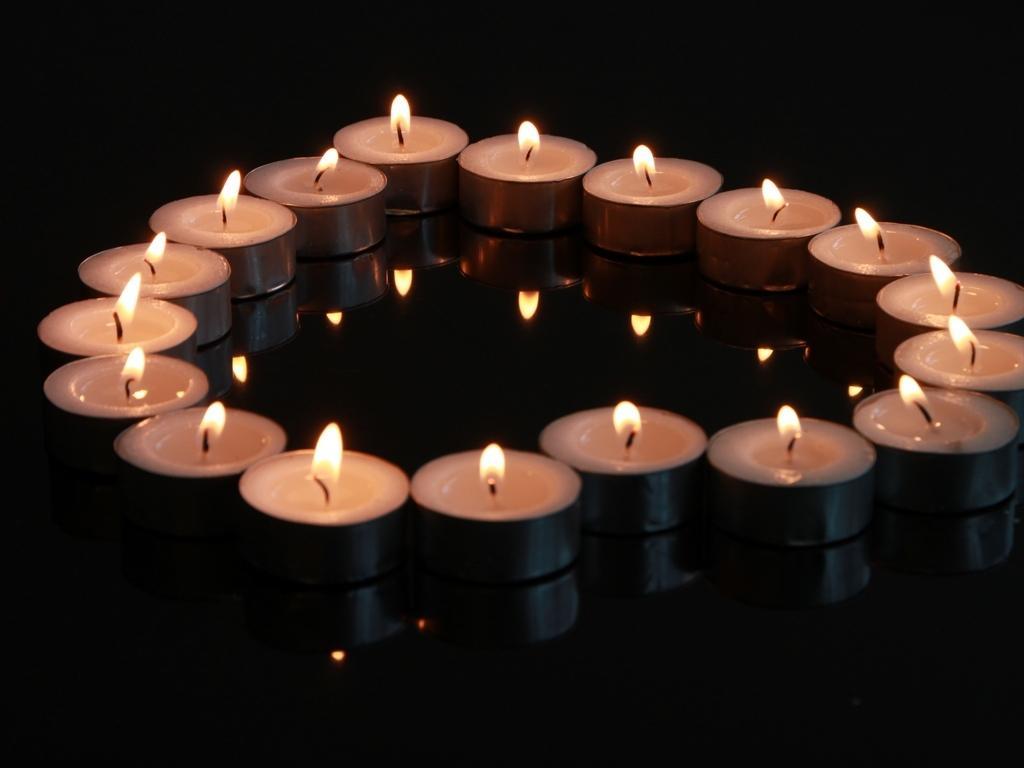Describe this image in one or two sentences. As we can see in the image there are candles and there is reflection of candles. The image is little dark. 